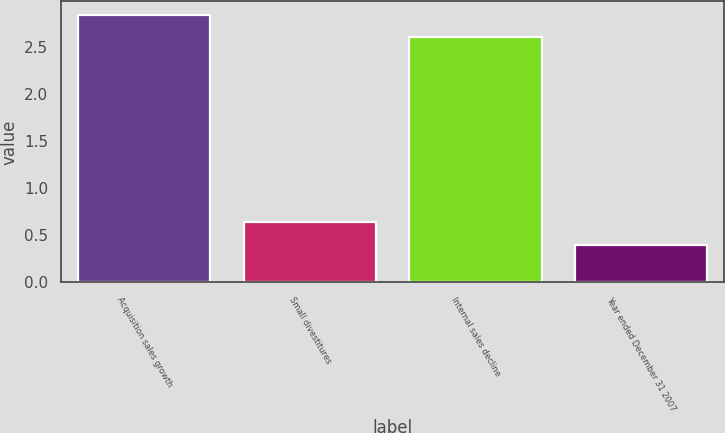Convert chart to OTSL. <chart><loc_0><loc_0><loc_500><loc_500><bar_chart><fcel>Acquisition sales growth<fcel>Small divestitures<fcel>Internal sales decline<fcel>Year ended December 31 2007<nl><fcel>2.84<fcel>0.64<fcel>2.6<fcel>0.4<nl></chart> 